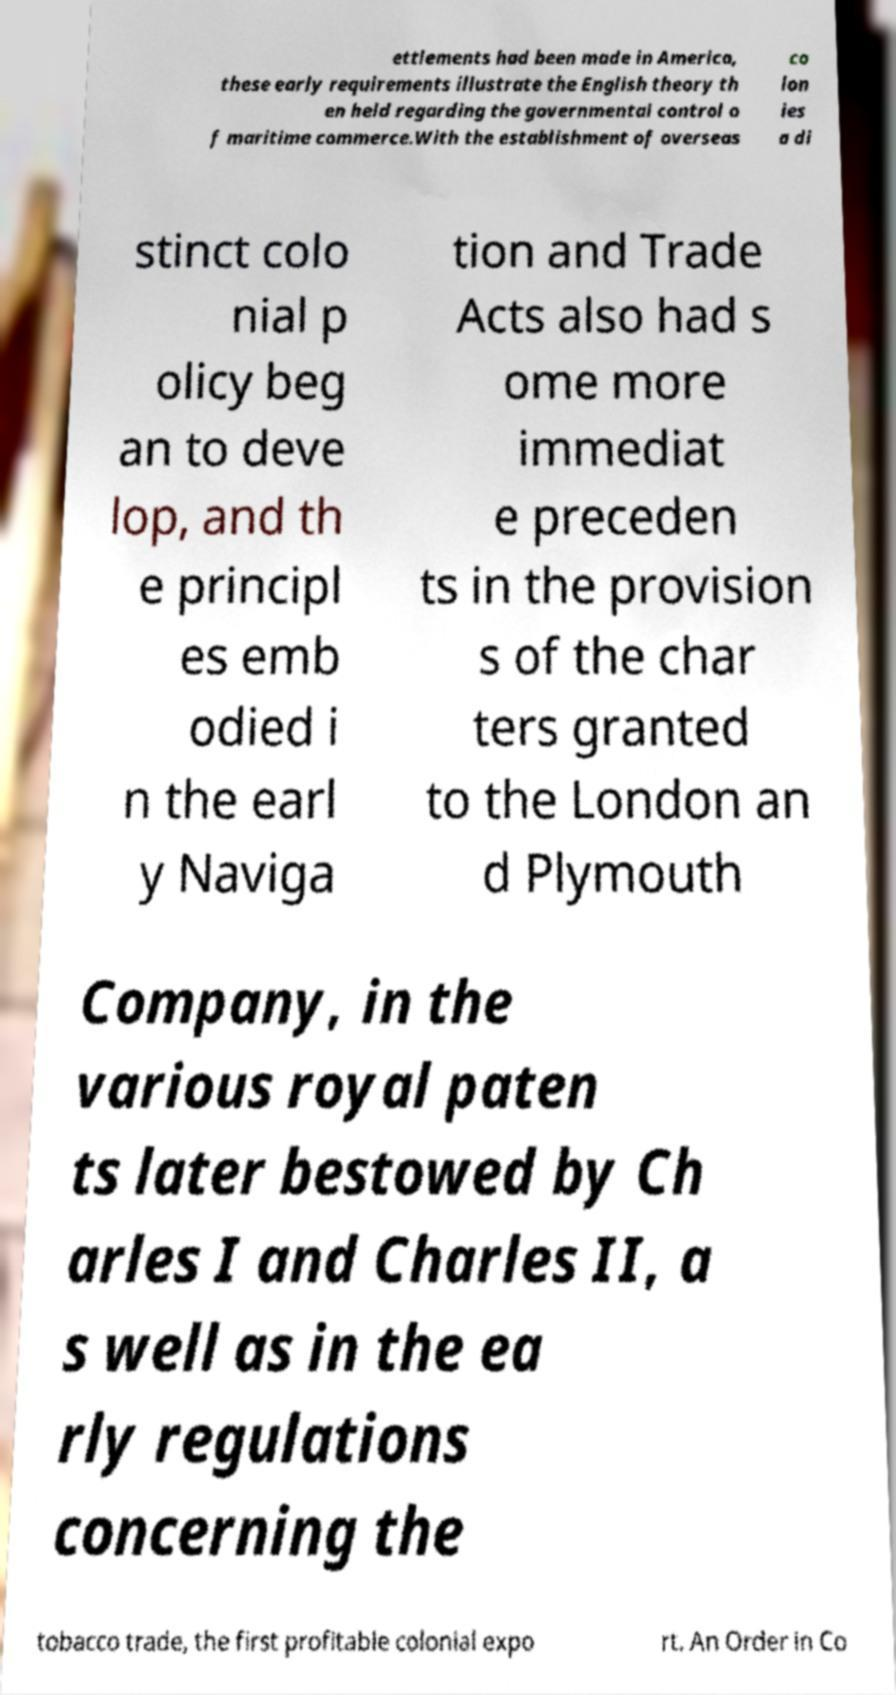There's text embedded in this image that I need extracted. Can you transcribe it verbatim? ettlements had been made in America, these early requirements illustrate the English theory th en held regarding the governmental control o f maritime commerce.With the establishment of overseas co lon ies a di stinct colo nial p olicy beg an to deve lop, and th e principl es emb odied i n the earl y Naviga tion and Trade Acts also had s ome more immediat e preceden ts in the provision s of the char ters granted to the London an d Plymouth Company, in the various royal paten ts later bestowed by Ch arles I and Charles II, a s well as in the ea rly regulations concerning the tobacco trade, the first profitable colonial expo rt. An Order in Co 